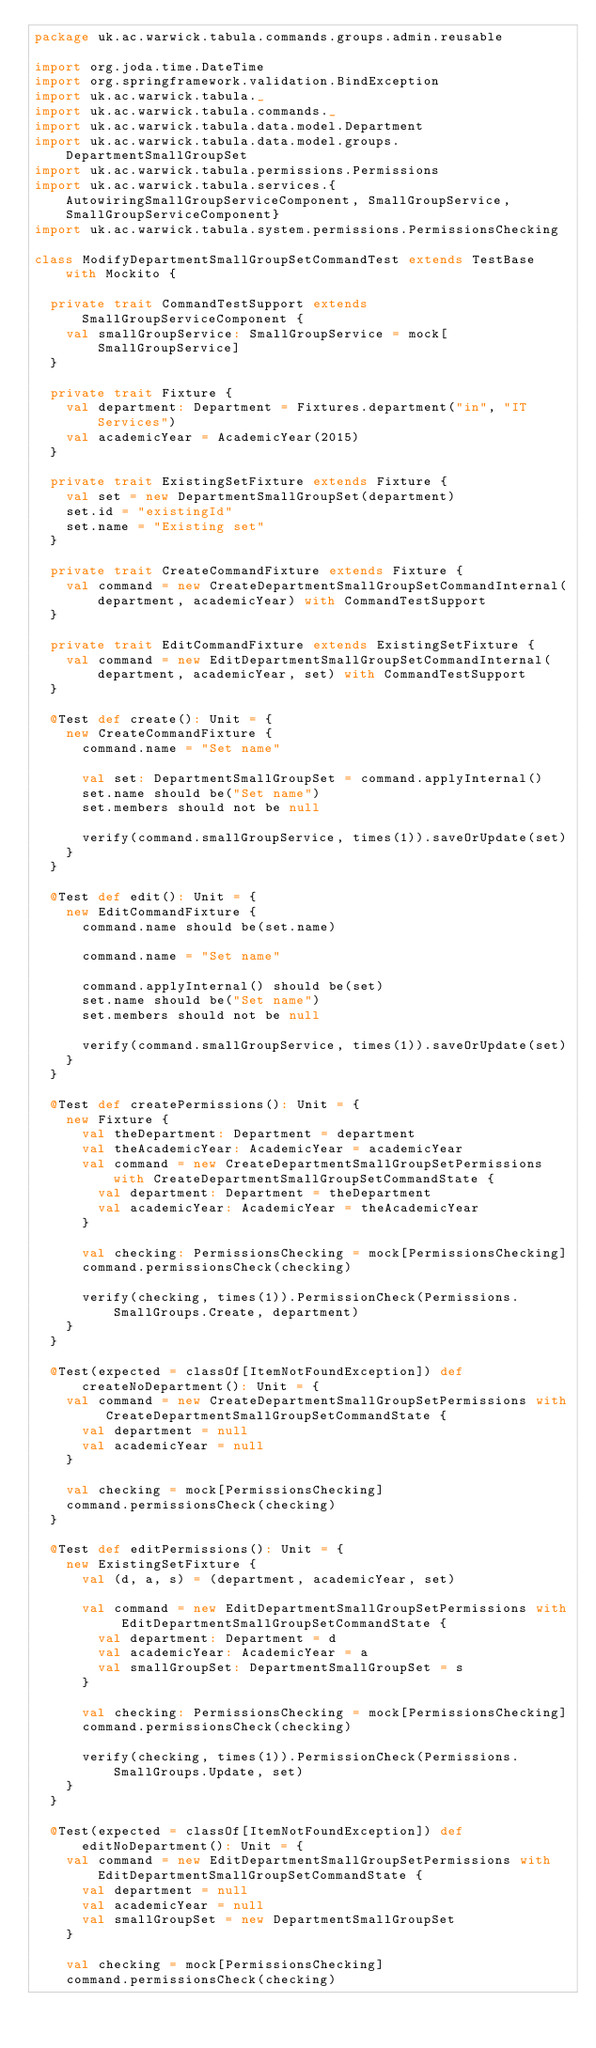Convert code to text. <code><loc_0><loc_0><loc_500><loc_500><_Scala_>package uk.ac.warwick.tabula.commands.groups.admin.reusable

import org.joda.time.DateTime
import org.springframework.validation.BindException
import uk.ac.warwick.tabula._
import uk.ac.warwick.tabula.commands._
import uk.ac.warwick.tabula.data.model.Department
import uk.ac.warwick.tabula.data.model.groups.DepartmentSmallGroupSet
import uk.ac.warwick.tabula.permissions.Permissions
import uk.ac.warwick.tabula.services.{AutowiringSmallGroupServiceComponent, SmallGroupService, SmallGroupServiceComponent}
import uk.ac.warwick.tabula.system.permissions.PermissionsChecking

class ModifyDepartmentSmallGroupSetCommandTest extends TestBase with Mockito {

  private trait CommandTestSupport extends SmallGroupServiceComponent {
    val smallGroupService: SmallGroupService = mock[SmallGroupService]
  }

  private trait Fixture {
    val department: Department = Fixtures.department("in", "IT Services")
    val academicYear = AcademicYear(2015)
  }

  private trait ExistingSetFixture extends Fixture {
    val set = new DepartmentSmallGroupSet(department)
    set.id = "existingId"
    set.name = "Existing set"
  }

  private trait CreateCommandFixture extends Fixture {
    val command = new CreateDepartmentSmallGroupSetCommandInternal(department, academicYear) with CommandTestSupport
  }

  private trait EditCommandFixture extends ExistingSetFixture {
    val command = new EditDepartmentSmallGroupSetCommandInternal(department, academicYear, set) with CommandTestSupport
  }

  @Test def create(): Unit = {
    new CreateCommandFixture {
      command.name = "Set name"

      val set: DepartmentSmallGroupSet = command.applyInternal()
      set.name should be("Set name")
      set.members should not be null

      verify(command.smallGroupService, times(1)).saveOrUpdate(set)
    }
  }

  @Test def edit(): Unit = {
    new EditCommandFixture {
      command.name should be(set.name)

      command.name = "Set name"

      command.applyInternal() should be(set)
      set.name should be("Set name")
      set.members should not be null

      verify(command.smallGroupService, times(1)).saveOrUpdate(set)
    }
  }

  @Test def createPermissions(): Unit = {
    new Fixture {
      val theDepartment: Department = department
      val theAcademicYear: AcademicYear = academicYear
      val command = new CreateDepartmentSmallGroupSetPermissions with CreateDepartmentSmallGroupSetCommandState {
        val department: Department = theDepartment
        val academicYear: AcademicYear = theAcademicYear
      }

      val checking: PermissionsChecking = mock[PermissionsChecking]
      command.permissionsCheck(checking)

      verify(checking, times(1)).PermissionCheck(Permissions.SmallGroups.Create, department)
    }
  }

  @Test(expected = classOf[ItemNotFoundException]) def createNoDepartment(): Unit = {
    val command = new CreateDepartmentSmallGroupSetPermissions with CreateDepartmentSmallGroupSetCommandState {
      val department = null
      val academicYear = null
    }

    val checking = mock[PermissionsChecking]
    command.permissionsCheck(checking)
  }

  @Test def editPermissions(): Unit = {
    new ExistingSetFixture {
      val (d, a, s) = (department, academicYear, set)

      val command = new EditDepartmentSmallGroupSetPermissions with EditDepartmentSmallGroupSetCommandState {
        val department: Department = d
        val academicYear: AcademicYear = a
        val smallGroupSet: DepartmentSmallGroupSet = s
      }

      val checking: PermissionsChecking = mock[PermissionsChecking]
      command.permissionsCheck(checking)

      verify(checking, times(1)).PermissionCheck(Permissions.SmallGroups.Update, set)
    }
  }

  @Test(expected = classOf[ItemNotFoundException]) def editNoDepartment(): Unit = {
    val command = new EditDepartmentSmallGroupSetPermissions with EditDepartmentSmallGroupSetCommandState {
      val department = null
      val academicYear = null
      val smallGroupSet = new DepartmentSmallGroupSet
    }

    val checking = mock[PermissionsChecking]
    command.permissionsCheck(checking)</code> 